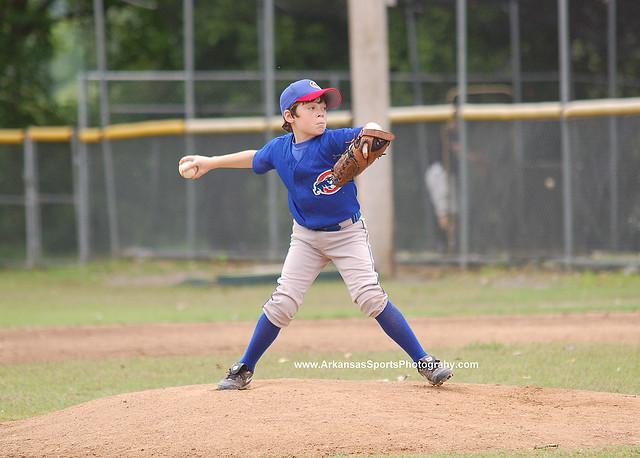What position does this kid play?
Be succinct. Pitcher. Is this kid right handed?
Answer briefly. Yes. What color socks is he wearing?
Quick response, please. Blue. Is this a pro baseball player?
Give a very brief answer. No. What position is this person playing?
Short answer required. Pitcher. What color is this child's uniform?
Give a very brief answer. Blue. 